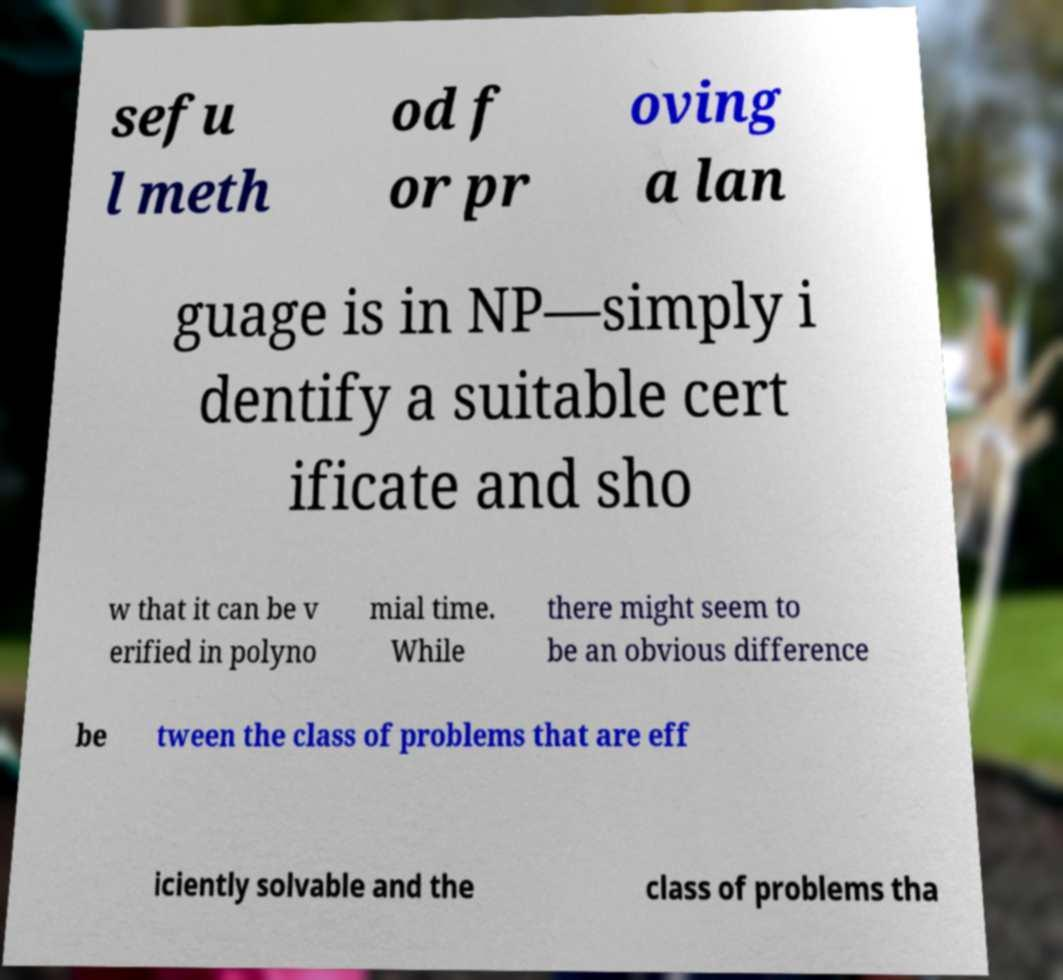Can you read and provide the text displayed in the image?This photo seems to have some interesting text. Can you extract and type it out for me? sefu l meth od f or pr oving a lan guage is in NP—simply i dentify a suitable cert ificate and sho w that it can be v erified in polyno mial time. While there might seem to be an obvious difference be tween the class of problems that are eff iciently solvable and the class of problems tha 